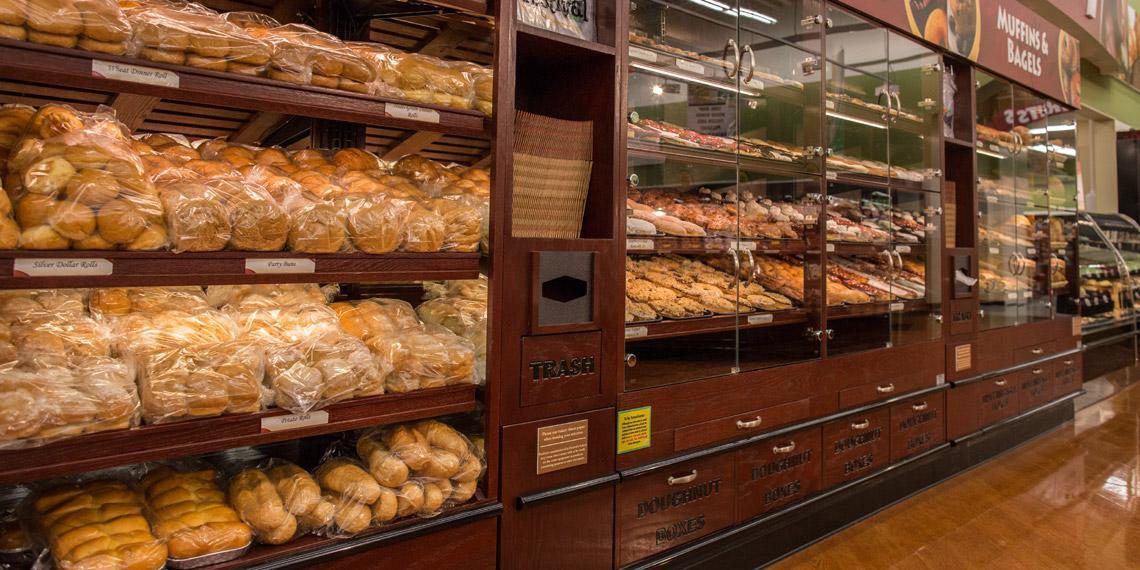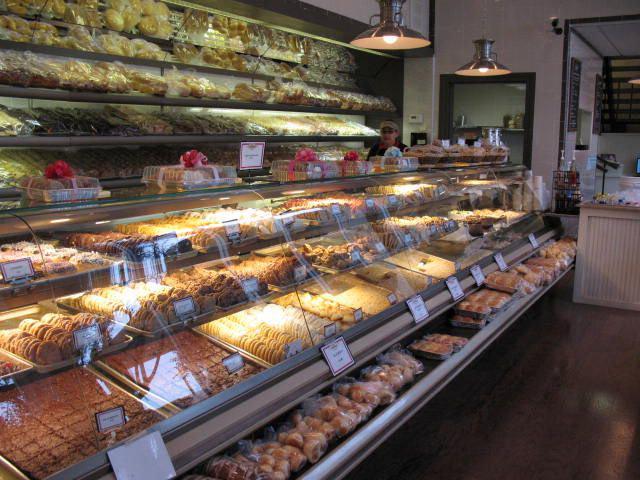The first image is the image on the left, the second image is the image on the right. For the images shown, is this caption "Only one person is visible in the image." true? Answer yes or no. Yes. The first image is the image on the left, the second image is the image on the right. Evaluate the accuracy of this statement regarding the images: "There are visible workers behind the the bakers cookie and brownie display case.". Is it true? Answer yes or no. Yes. 